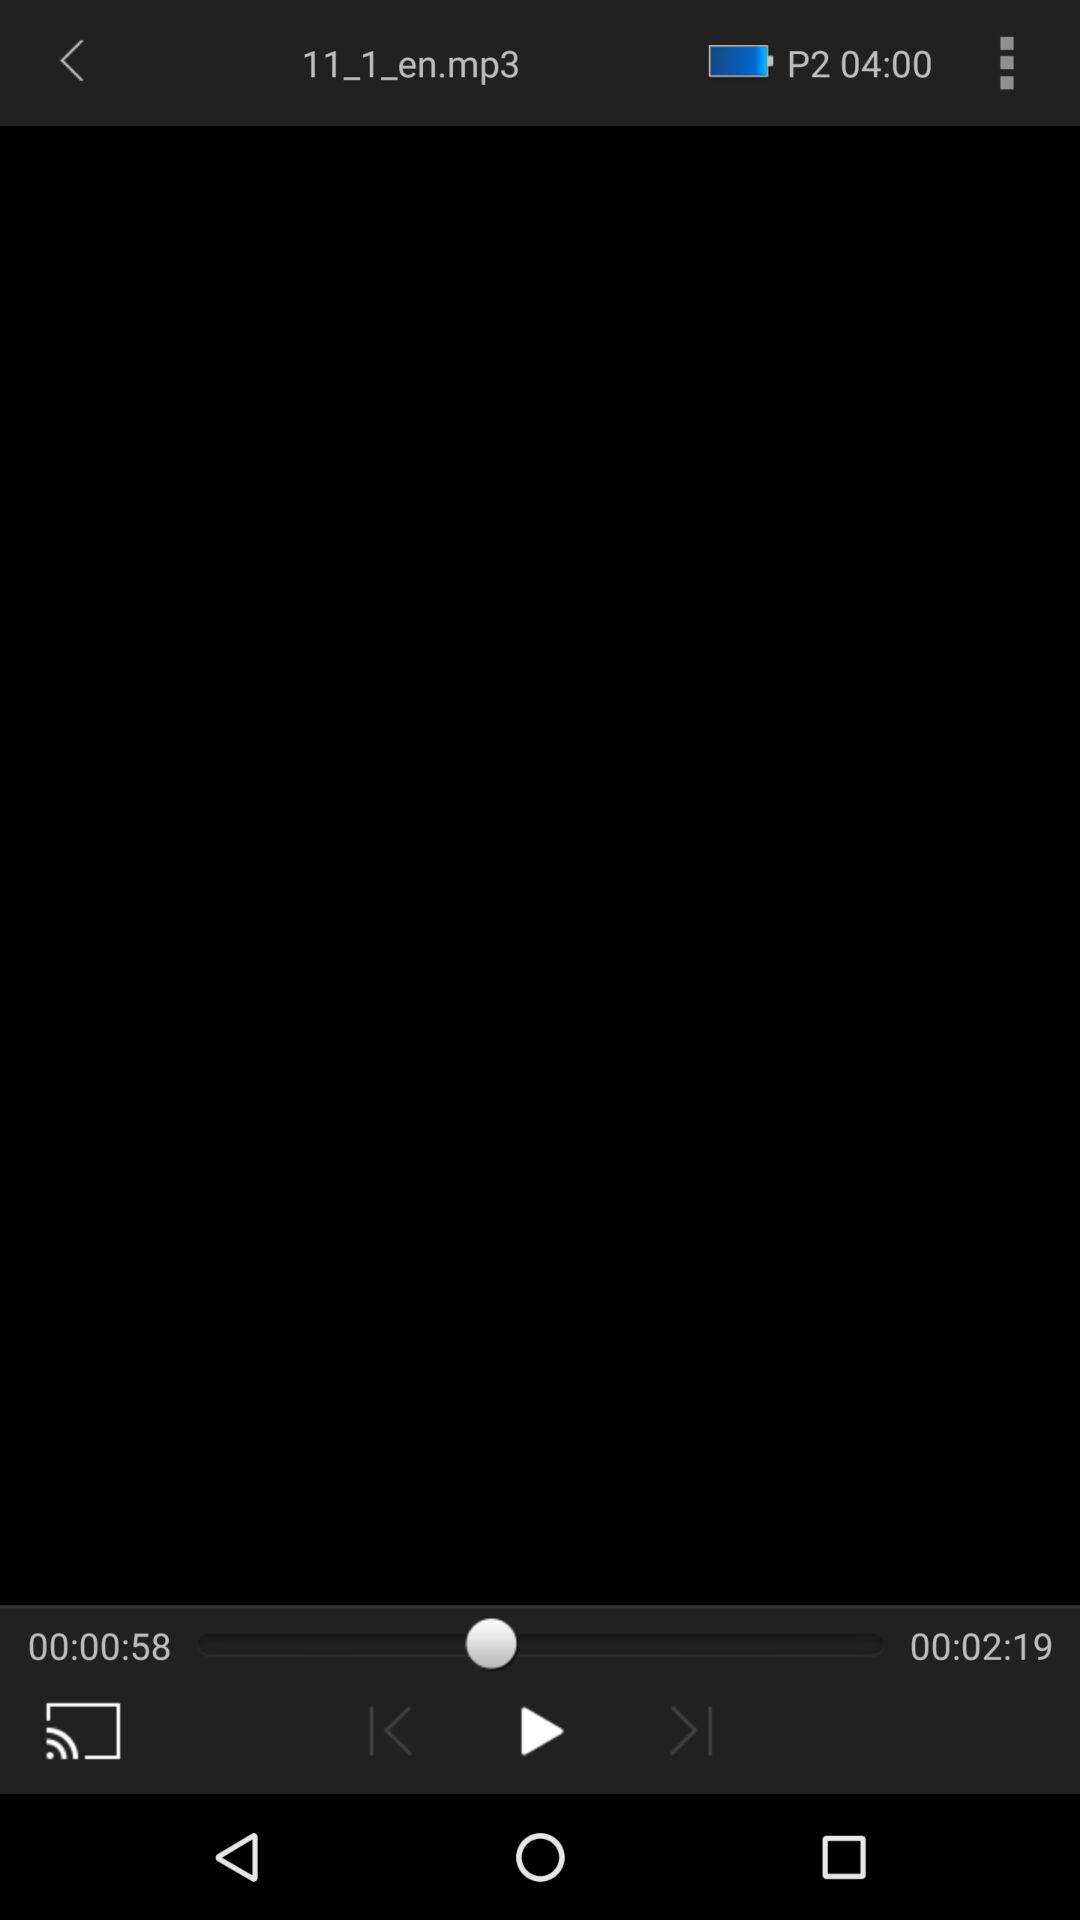What is the elapsed time of the audio? The elapsed time of the audio is 58 seconds. 